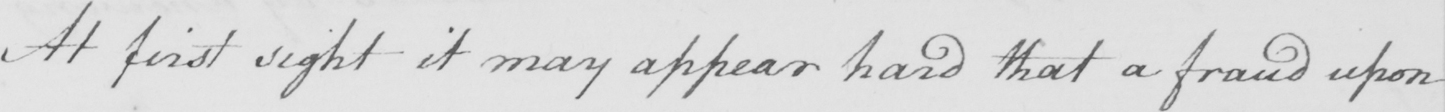Please transcribe the handwritten text in this image. At first sight it may appear hard that a fraud upon 